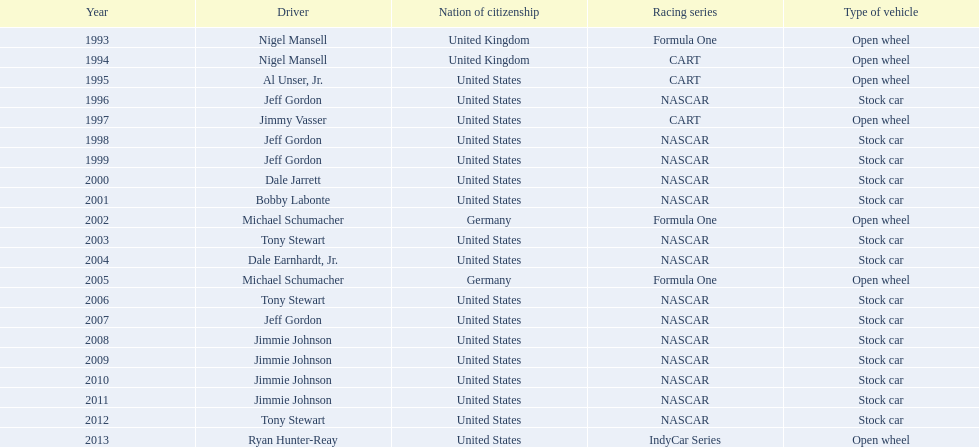Who was the espy recipient in 2004 - bobby labonte, tony stewart, dale earnhardt jr., or jeff gordon? Dale Earnhardt, Jr. Also, who claimed the espy in 1997: nigel mansell, al unser jr., jeff gordon, or jimmy vasser? Jimmy Vasser. Finally, which individual has only one espy to their name: nigel mansell, al unser jr., michael schumacher, or jeff gordon? Al Unser, Jr. 